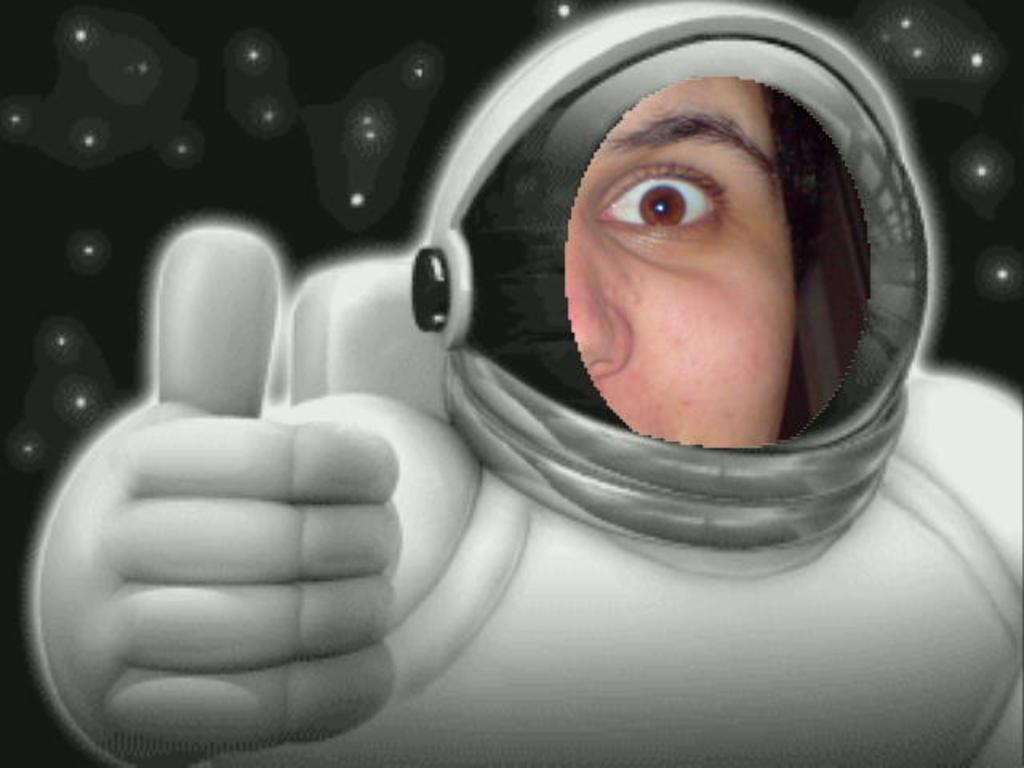What can be observed about the image itself? The image is edited. Who or what is present in the image? There is a person in the image. What is the person wearing? The person is wearing a space suit. What type of approval is the person seeking in the image? There is no indication in the image that the person is seeking any type of approval. Can you see any ducks in the image? There are no ducks present in the image. 